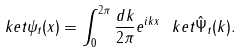Convert formula to latex. <formula><loc_0><loc_0><loc_500><loc_500>\ k e t { \psi _ { t } ( x ) } = \int _ { 0 } ^ { 2 \pi } \frac { d k } { 2 \pi } e ^ { i k x } \ k e t { \hat { \Psi } _ { t } ( k ) } .</formula> 